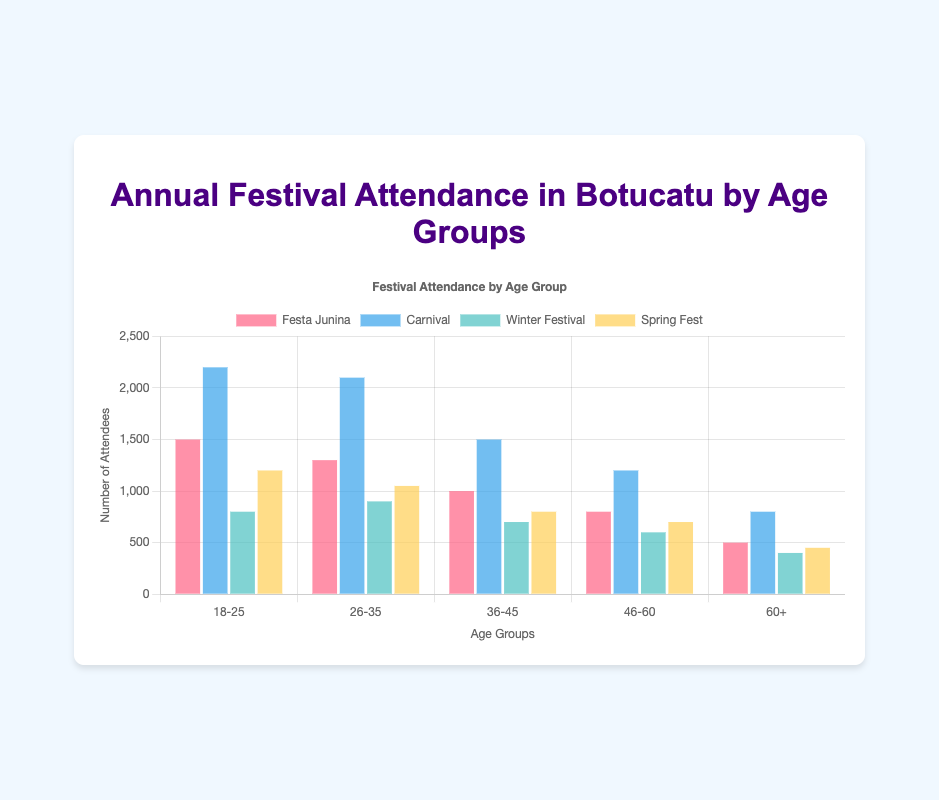Which age group has the highest attendance for Carnival? Look at all the bars representing Carnival for different age groups. The bar for "18-25" is the highest with a value of 2200.
Answer: 18-25 Which festival has the lowest attendance in the 60+ age group? Find the values for all festivals in the 60+ age group. "Winter Festival" has the lowest attendance at 400.
Answer: Winter Festival What is the difference in Spring Fest attendance between the youngest and oldest age groups? Look at the Spring Fest values for "18-25" (1200) and "60+" (450). Calculate the difference: 1200 - 450 = 750.
Answer: 750 Which age group has the smallest difference in attendance between Festa Junina and Carnival? Calculate the differences for each age group:
- 18-25: 2200 - 1500 = 700
- 26-35: 2100 - 1300 = 800
- 36-45: 1500 - 1000 = 500
- 46-60: 1200 - 800 = 400
- 60+: 800 - 500 = 300. The smallest difference is in the 60+ age group with 300.
Answer: 60+ For the 26-35 age group, which festival has the highest attendance, and what is that value? Look at the values for the 26-35 age group. "Carnival" has the highest attendance with 2100 attendees.
Answer: Carnival, 2100 How does the attendance for Winter Festival compare between the 18-25 and 36-45 age groups? Look at the Winter Festival values for "18-25" (800) and "36-45" (700). The attendance for the Winter Festival is higher in the 18-25 age group compared to the 36-45 age group by 100.
Answer: Higher by 100 Calculate the total festival attendance for the 36-45 age group across all festivals. Sum the values for the 36-45 age group:
Festa Junina (1000) + Carnival (1500) + Winter Festival (700) + Spring Fest (800) = 4000.
Answer: 4000 Which festival has consistent attendance below 1000 across all age groups? Check for each festival: "Winter Festival" has attendance values of 800, 900, 700, 600, and 400 across all age groups, all below 1000.
Answer: Winter Festival What is the average attendance for Festa Junina across all age groups? Sum up the Festa Junina values: 1500 + 1300 + 1000 + 800 + 500 = 5100. Then divide by the number of age groups (5): 5100 / 5 = 1020.
Answer: 1020 